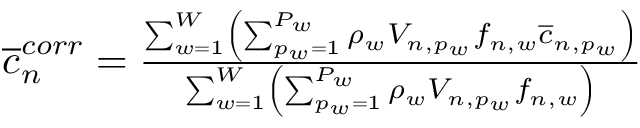Convert formula to latex. <formula><loc_0><loc_0><loc_500><loc_500>\begin{array} { r } { \overline { c } _ { n } ^ { c o r r } = \frac { \sum _ { w = 1 } ^ { W } \left ( \sum _ { p _ { w } = 1 } ^ { P _ { w } } \rho _ { w } V _ { n , p _ { w } } f _ { n , w } \overline { c } _ { n , p _ { w } } \right ) } { \sum _ { w = 1 } ^ { W } \left ( \sum _ { p _ { w } = 1 } ^ { P _ { w } } \rho _ { w } V _ { n , p _ { w } } f _ { n , w } \right ) } } \end{array}</formula> 